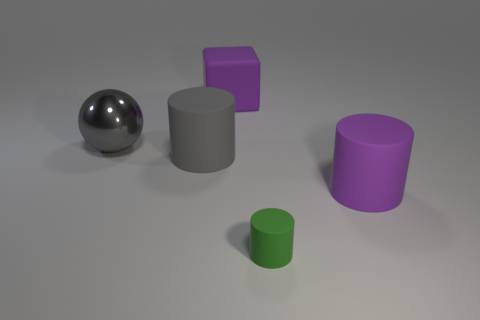What number of other objects are the same shape as the tiny object?
Offer a very short reply. 2. What size is the matte cylinder that is the same color as the large cube?
Offer a very short reply. Large. What material is the large cylinder that is the same color as the big cube?
Offer a terse response. Rubber. Are there any rubber objects of the same color as the big rubber block?
Offer a terse response. Yes. Are there more big purple matte things that are behind the large gray shiny thing than purple cubes that are on the right side of the tiny green cylinder?
Provide a succinct answer. Yes. Is there a purple thing that has the same material as the cube?
Ensure brevity in your answer.  Yes. What is the material of the thing that is behind the tiny green rubber cylinder and right of the large rubber block?
Offer a terse response. Rubber. The matte block is what color?
Offer a terse response. Purple. What number of other tiny green matte things are the same shape as the tiny thing?
Provide a short and direct response. 0. Does the gray object that is in front of the gray shiny object have the same material as the sphere to the left of the small green rubber cylinder?
Offer a terse response. No. 